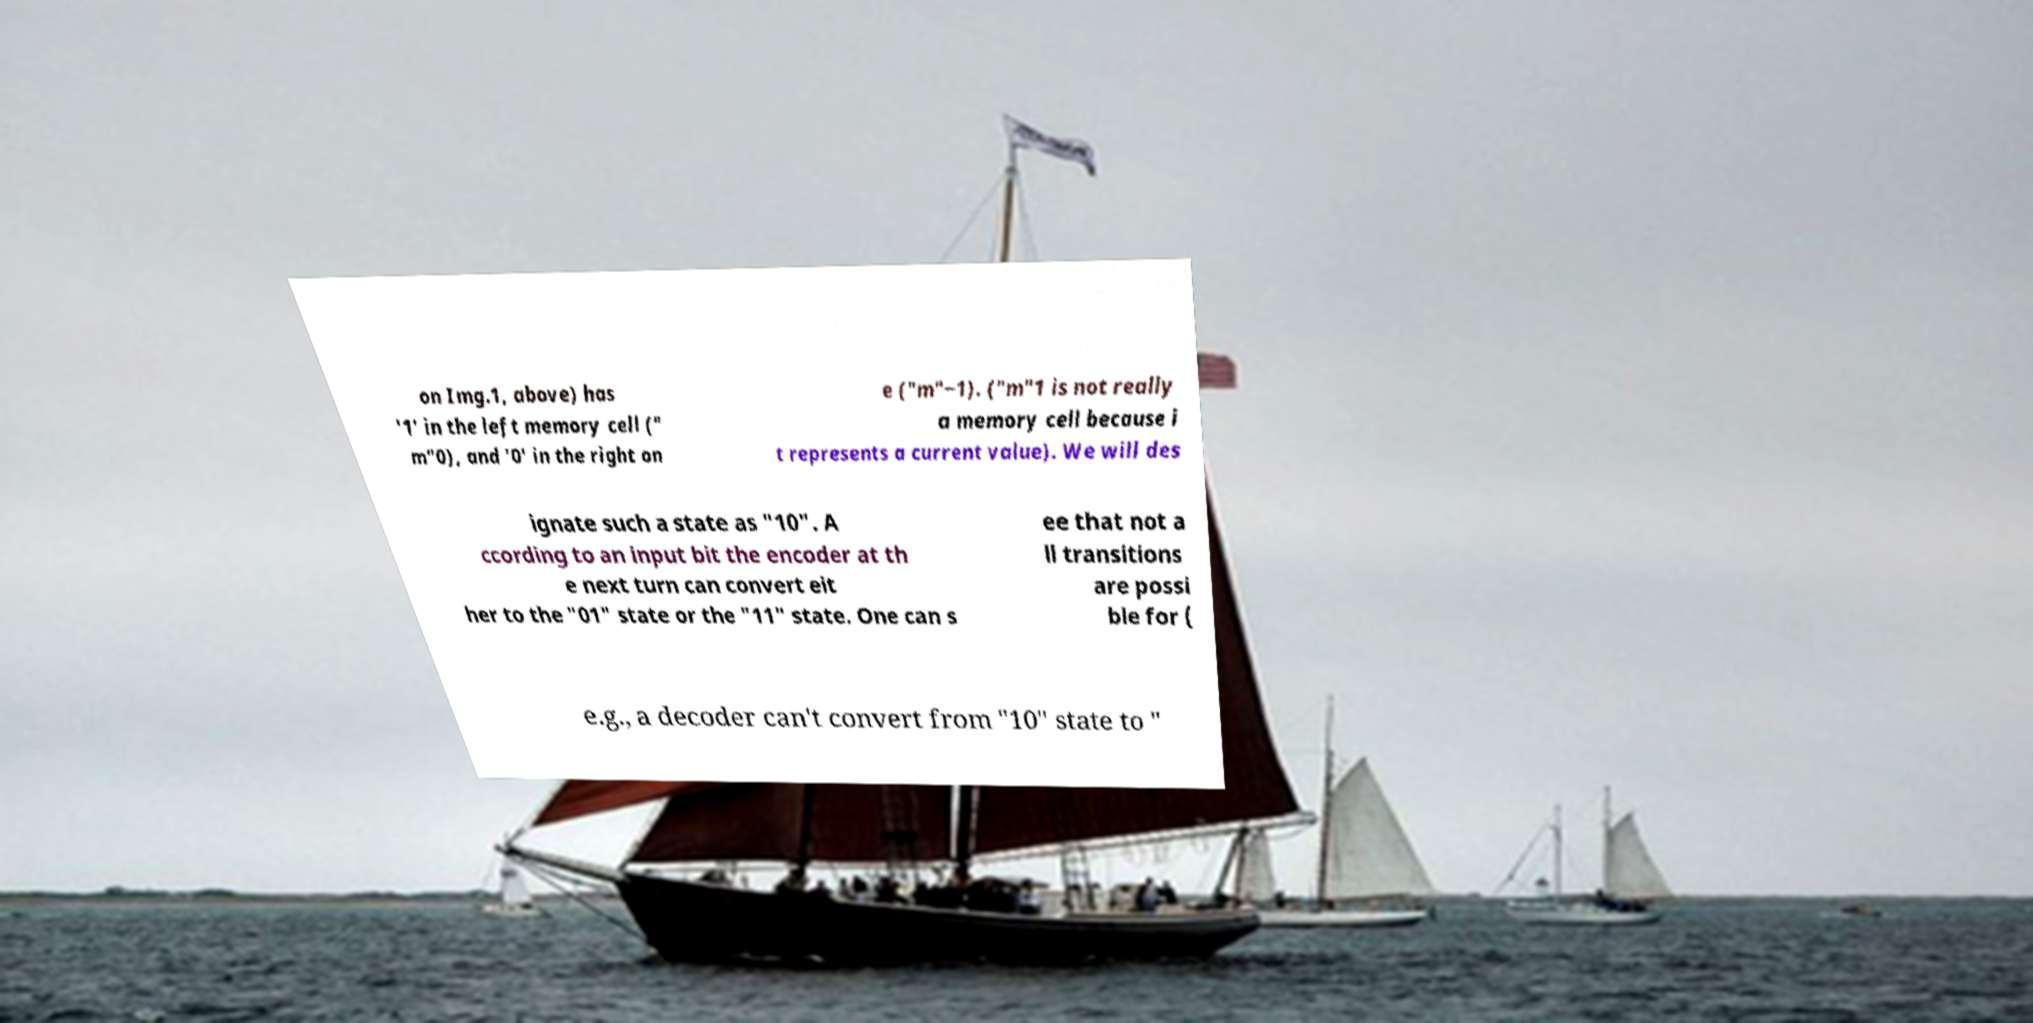Can you accurately transcribe the text from the provided image for me? on Img.1, above) has '1' in the left memory cell (" m"0), and '0' in the right on e ("m"−1). ("m"1 is not really a memory cell because i t represents a current value). We will des ignate such a state as "10". A ccording to an input bit the encoder at th e next turn can convert eit her to the "01" state or the "11" state. One can s ee that not a ll transitions are possi ble for ( e.g., a decoder can't convert from "10" state to " 